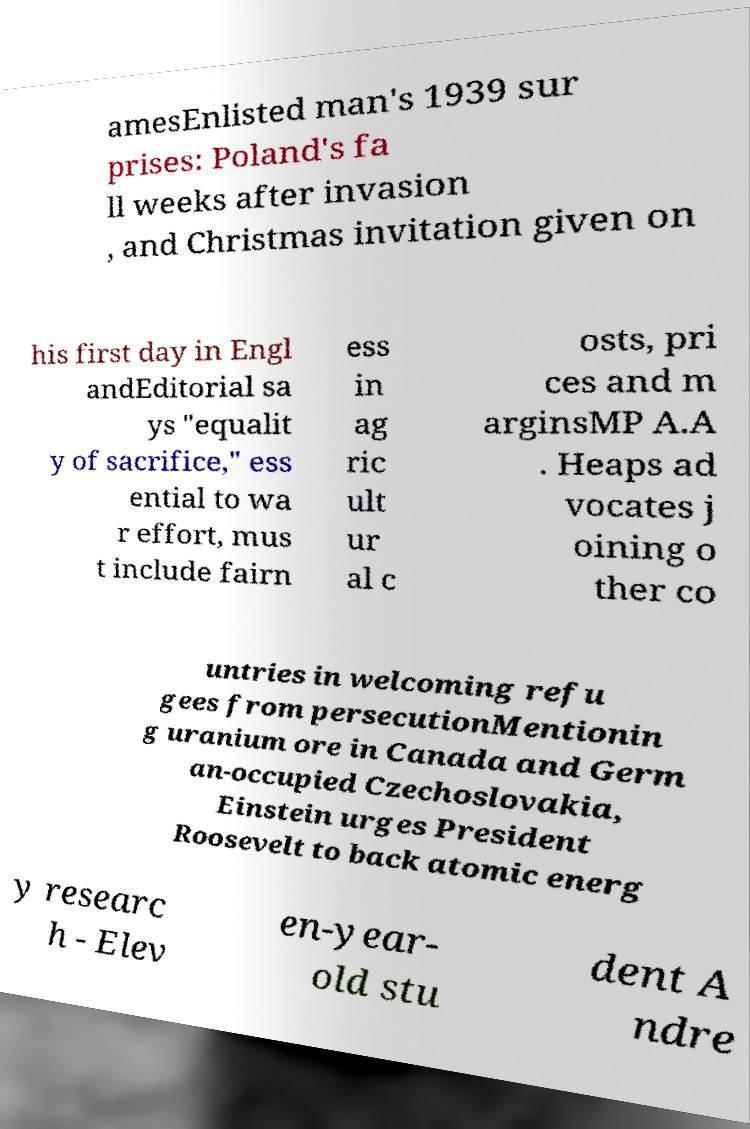Please read and relay the text visible in this image. What does it say? amesEnlisted man's 1939 sur prises: Poland's fa ll weeks after invasion , and Christmas invitation given on his first day in Engl andEditorial sa ys "equalit y of sacrifice," ess ential to wa r effort, mus t include fairn ess in ag ric ult ur al c osts, pri ces and m arginsMP A.A . Heaps ad vocates j oining o ther co untries in welcoming refu gees from persecutionMentionin g uranium ore in Canada and Germ an-occupied Czechoslovakia, Einstein urges President Roosevelt to back atomic energ y researc h - Elev en-year- old stu dent A ndre 